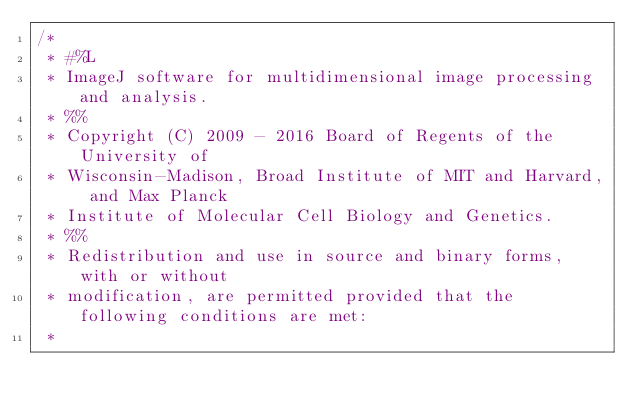Convert code to text. <code><loc_0><loc_0><loc_500><loc_500><_Java_>/*
 * #%L
 * ImageJ software for multidimensional image processing and analysis.
 * %%
 * Copyright (C) 2009 - 2016 Board of Regents of the University of
 * Wisconsin-Madison, Broad Institute of MIT and Harvard, and Max Planck
 * Institute of Molecular Cell Biology and Genetics.
 * %%
 * Redistribution and use in source and binary forms, with or without
 * modification, are permitted provided that the following conditions are met:
 * </code> 